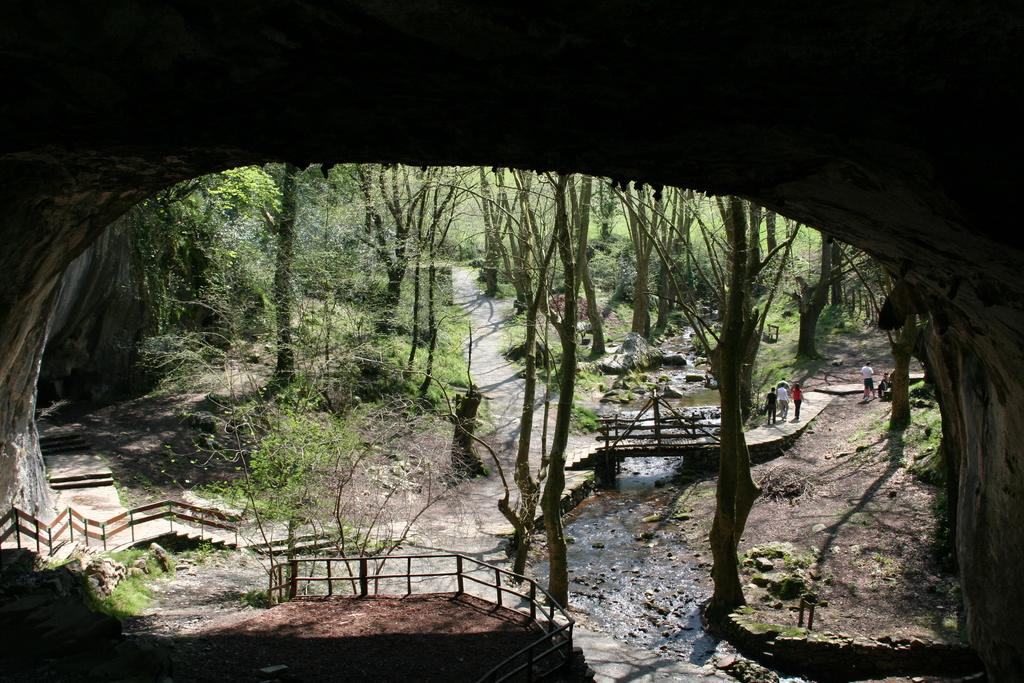How many people are present in the image? There are persons standing in the image. What is the primary feature visible in the image? There is water visible in the image. What type of structure can be seen in the image? There is a bridge in the image. What type of barrier is present in the image? There is a fence in the image. What type of vegetation is present in the image? There are plants in the image. What can be seen in the background of the image? There are trees in the background of the image. What type of baseball equipment can be seen in the image? There is no baseball equipment present in the image. What type of tool is used for cutting in the image? There are no scissors or cutting tools present in the image. 